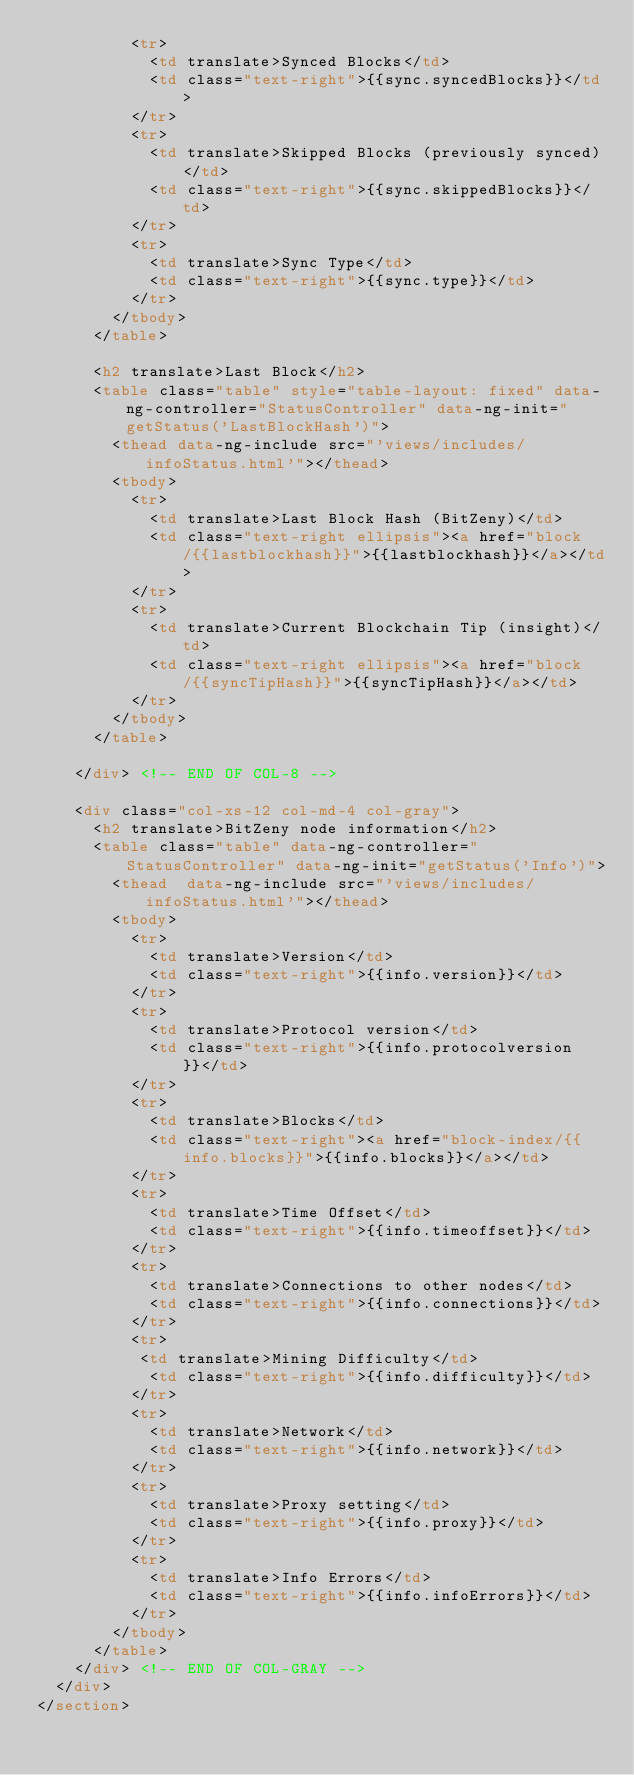Convert code to text. <code><loc_0><loc_0><loc_500><loc_500><_HTML_>          <tr>
            <td translate>Synced Blocks</td>
            <td class="text-right">{{sync.syncedBlocks}}</td>
          </tr>
          <tr>
            <td translate>Skipped Blocks (previously synced)</td>
            <td class="text-right">{{sync.skippedBlocks}}</td>
          </tr>
          <tr>
            <td translate>Sync Type</td>
            <td class="text-right">{{sync.type}}</td>
          </tr>
        </tbody>
      </table>

      <h2 translate>Last Block</h2>
      <table class="table" style="table-layout: fixed" data-ng-controller="StatusController" data-ng-init="getStatus('LastBlockHash')">
        <thead data-ng-include src="'views/includes/infoStatus.html'"></thead>
        <tbody>
          <tr>
            <td translate>Last Block Hash (BitZeny)</td>
            <td class="text-right ellipsis"><a href="block/{{lastblockhash}}">{{lastblockhash}}</a></td>
          </tr>
          <tr>
            <td translate>Current Blockchain Tip (insight)</td>
            <td class="text-right ellipsis"><a href="block/{{syncTipHash}}">{{syncTipHash}}</a></td>
          </tr>
        </tbody>
      </table>

    </div> <!-- END OF COL-8 -->

    <div class="col-xs-12 col-md-4 col-gray">
      <h2 translate>BitZeny node information</h2>
      <table class="table" data-ng-controller="StatusController" data-ng-init="getStatus('Info')">
        <thead  data-ng-include src="'views/includes/infoStatus.html'"></thead>
        <tbody>
          <tr>
            <td translate>Version</td>
            <td class="text-right">{{info.version}}</td>
          </tr>
          <tr>
            <td translate>Protocol version</td>
            <td class="text-right">{{info.protocolversion}}</td>
          </tr>
          <tr>
            <td translate>Blocks</td>
            <td class="text-right"><a href="block-index/{{info.blocks}}">{{info.blocks}}</a></td>
          </tr>
          <tr>
            <td translate>Time Offset</td>
            <td class="text-right">{{info.timeoffset}}</td>
          </tr>
          <tr>
            <td translate>Connections to other nodes</td>
            <td class="text-right">{{info.connections}}</td>
          </tr>
          <tr>
           <td translate>Mining Difficulty</td>
            <td class="text-right">{{info.difficulty}}</td>
          </tr>
          <tr>
            <td translate>Network</td>
            <td class="text-right">{{info.network}}</td>
          </tr>
          <tr>
            <td translate>Proxy setting</td>
            <td class="text-right">{{info.proxy}}</td>
          </tr>
          <tr>
            <td translate>Info Errors</td>
            <td class="text-right">{{info.infoErrors}}</td>
          </tr>
        </tbody>
      </table>
    </div> <!-- END OF COL-GRAY -->
  </div>
</section>

</code> 